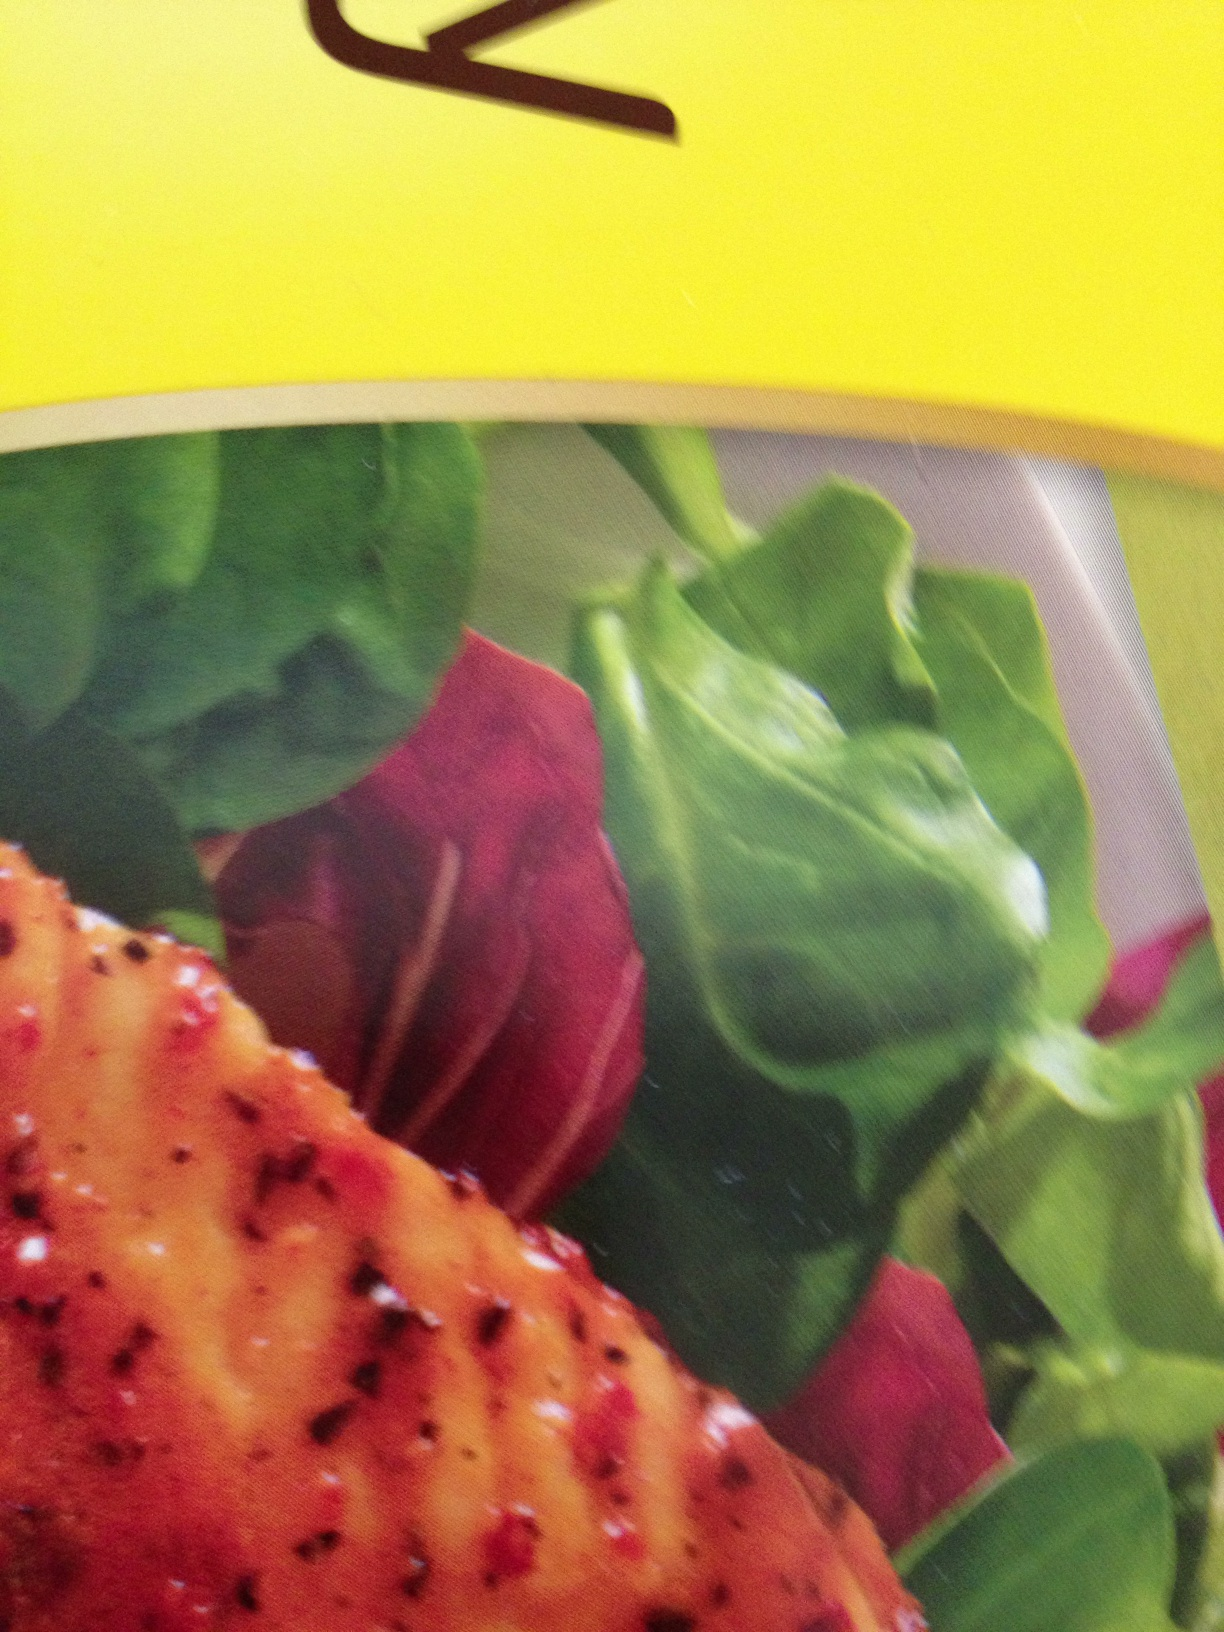Can you describe the flavors and ingredients you think are in this dish? Based on the image, this dish likely features a flavorful grilled or roasted meat, possibly chicken or fish, seasoned with herbs and spices. Accompanying the meat are fresh salad greens and slices of red vegetables like beets, adding both color and nutrition. 